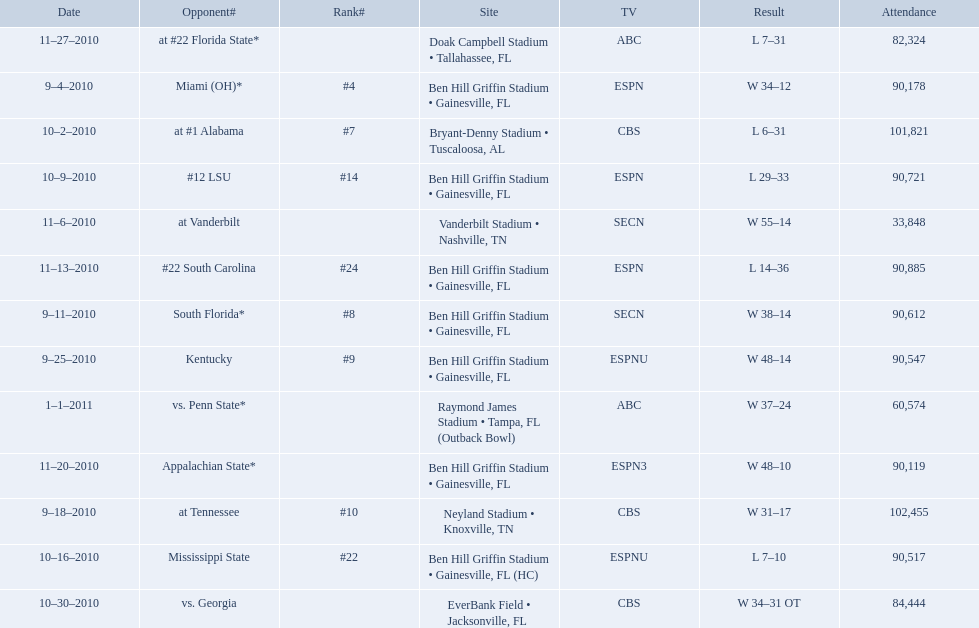What was the highest winning difference for the university of florida? 41 points. 